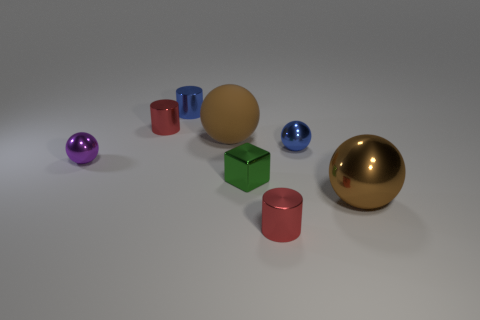How many objects are either large things left of the tiny green metallic object or cyan metal cylinders?
Your answer should be very brief. 1. Is there a large purple matte block?
Keep it short and to the point. No. What is the shape of the tiny metallic object that is both on the right side of the green metallic object and in front of the purple metallic thing?
Your answer should be compact. Cylinder. How big is the blue shiny thing right of the blue cylinder?
Provide a succinct answer. Small. Do the cylinder that is in front of the tiny blue sphere and the small block have the same color?
Keep it short and to the point. No. How many tiny green metallic objects have the same shape as the tiny purple object?
Your answer should be very brief. 0. What number of objects are blue shiny things in front of the big matte object or large things behind the purple metal thing?
Provide a succinct answer. 2. What number of red objects are large objects or cylinders?
Keep it short and to the point. 2. What is the material of the tiny object that is both on the left side of the green shiny object and in front of the blue sphere?
Your answer should be very brief. Metal. Does the tiny purple sphere have the same material as the small blue ball?
Offer a terse response. Yes. 